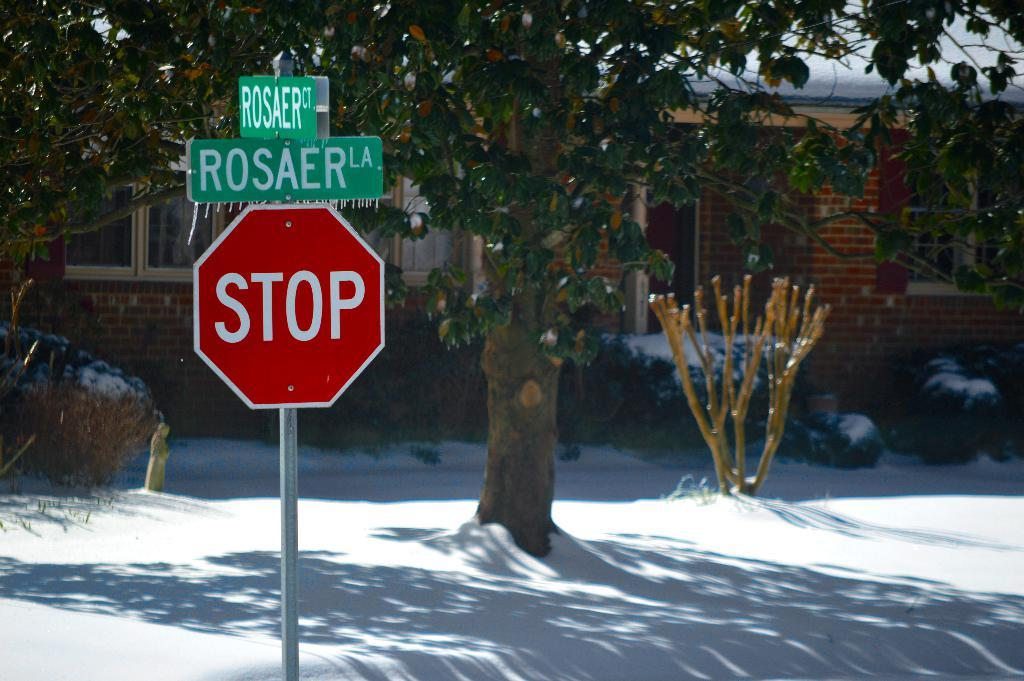<image>
Offer a succinct explanation of the picture presented. A stop sign at the intersection of Rosaer lane and Rosaer Court 